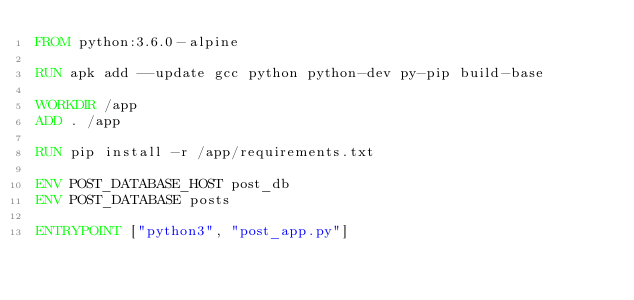<code> <loc_0><loc_0><loc_500><loc_500><_Dockerfile_>FROM python:3.6.0-alpine

RUN apk add --update gcc python python-dev py-pip build-base

WORKDIR /app
ADD . /app

RUN pip install -r /app/requirements.txt

ENV POST_DATABASE_HOST post_db
ENV POST_DATABASE posts

ENTRYPOINT ["python3", "post_app.py"]
</code> 